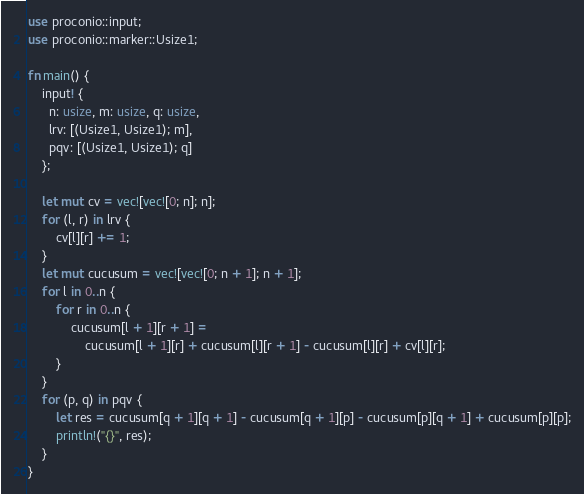Convert code to text. <code><loc_0><loc_0><loc_500><loc_500><_Rust_>use proconio::input;
use proconio::marker::Usize1;

fn main() {
    input! {
      n: usize, m: usize, q: usize,
      lrv: [(Usize1, Usize1); m],
      pqv: [(Usize1, Usize1); q]
    };

    let mut cv = vec![vec![0; n]; n];
    for (l, r) in lrv {
        cv[l][r] += 1;
    }
    let mut cucusum = vec![vec![0; n + 1]; n + 1];
    for l in 0..n {
        for r in 0..n {
            cucusum[l + 1][r + 1] =
                cucusum[l + 1][r] + cucusum[l][r + 1] - cucusum[l][r] + cv[l][r];
        }
    }
    for (p, q) in pqv {
        let res = cucusum[q + 1][q + 1] - cucusum[q + 1][p] - cucusum[p][q + 1] + cucusum[p][p];
        println!("{}", res);
    }
}
</code> 